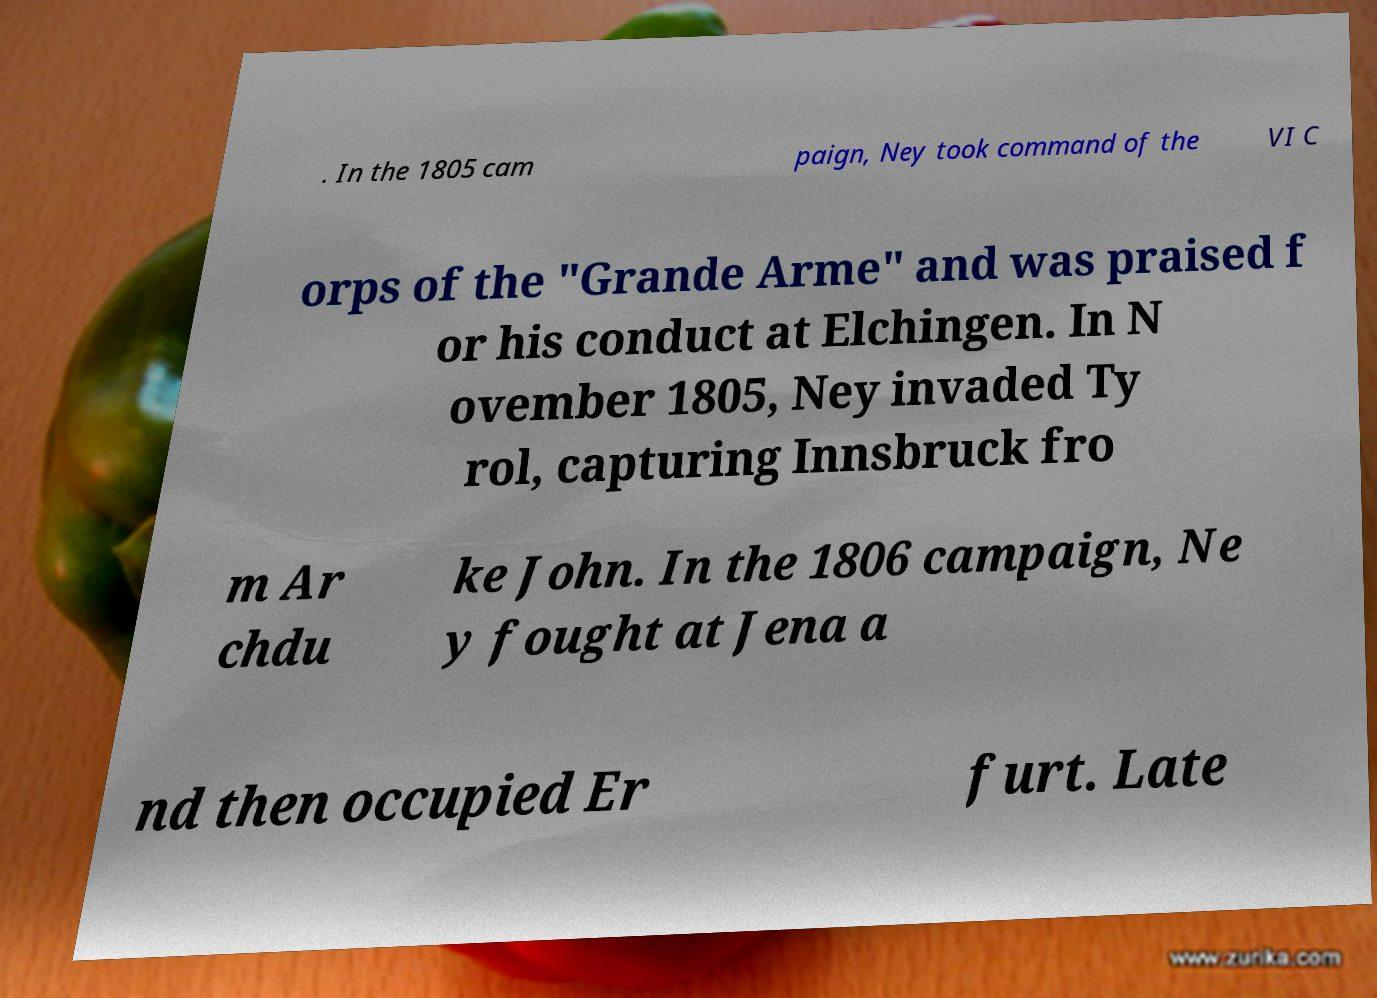There's text embedded in this image that I need extracted. Can you transcribe it verbatim? . In the 1805 cam paign, Ney took command of the VI C orps of the "Grande Arme" and was praised f or his conduct at Elchingen. In N ovember 1805, Ney invaded Ty rol, capturing Innsbruck fro m Ar chdu ke John. In the 1806 campaign, Ne y fought at Jena a nd then occupied Er furt. Late 